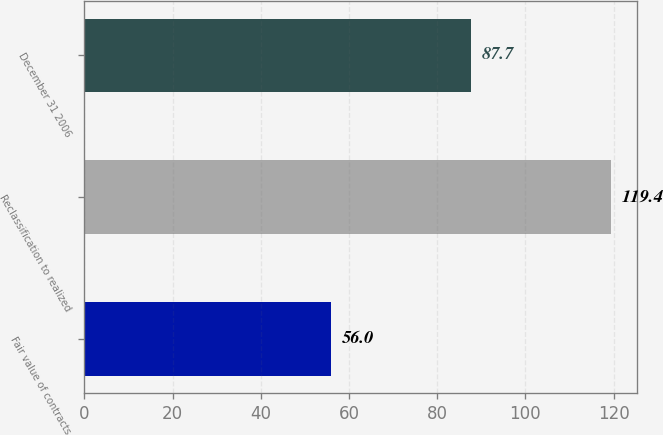Convert chart. <chart><loc_0><loc_0><loc_500><loc_500><bar_chart><fcel>Fair value of contracts<fcel>Reclassification to realized<fcel>December 31 2006<nl><fcel>56<fcel>119.4<fcel>87.7<nl></chart> 